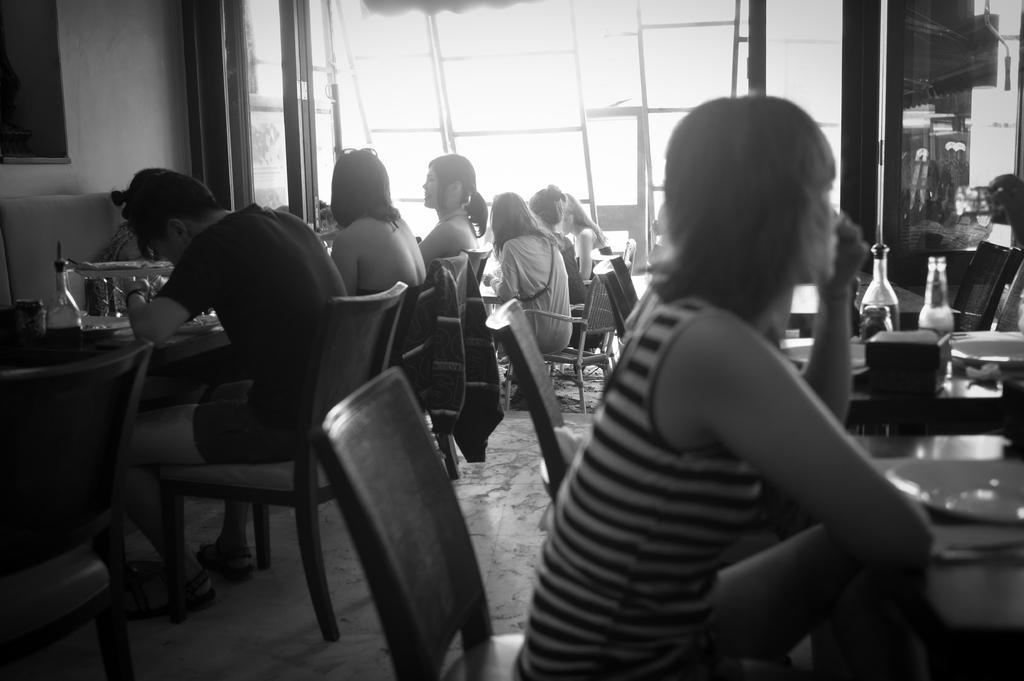Can you describe this image briefly? These persons are sitting on the chairs. We can see bottles,plates on the tables. On the background we can see wall. 